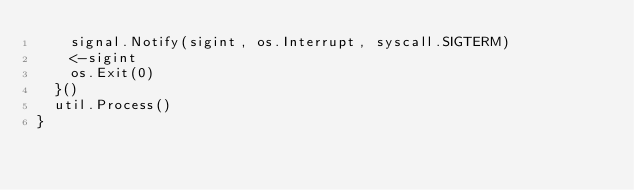<code> <loc_0><loc_0><loc_500><loc_500><_Go_>		signal.Notify(sigint, os.Interrupt, syscall.SIGTERM)
		<-sigint
		os.Exit(0)
	}()
	util.Process()
}
</code> 